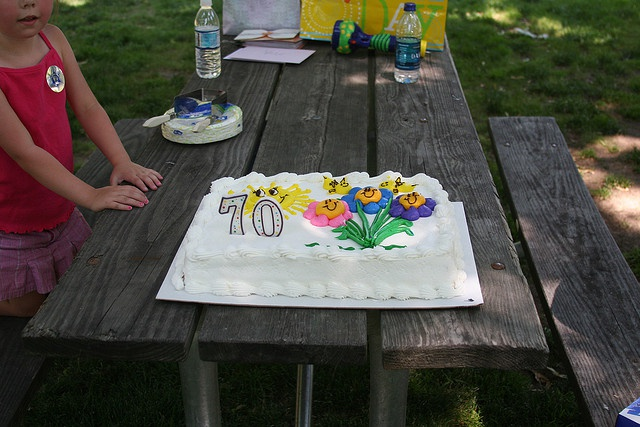Describe the objects in this image and their specific colors. I can see dining table in brown, black, gray, lightgray, and darkgray tones, cake in brown, lightgray, darkgray, and gray tones, people in brown, maroon, and black tones, bench in brown, gray, and black tones, and bench in brown and black tones in this image. 